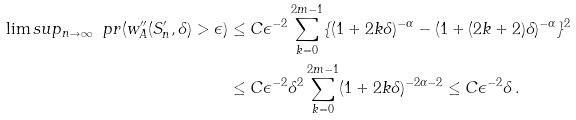Convert formula to latex. <formula><loc_0><loc_0><loc_500><loc_500>\lim s u p _ { n \to \infty } \ p r ( w _ { A } ^ { \prime \prime } ( S _ { n } ^ { \prime } , \delta ) > \epsilon ) & \leq C \epsilon ^ { - 2 } \sum _ { k = 0 } ^ { 2 m - 1 } \{ ( 1 + 2 k \delta ) ^ { - \alpha } - ( 1 + ( 2 k + 2 ) \delta ) ^ { - \alpha } \} ^ { 2 } \\ & \leq C \epsilon ^ { - 2 } \delta ^ { 2 } \sum _ { k = 0 } ^ { 2 m - 1 } ( 1 + 2 k \delta ) ^ { - 2 \alpha - 2 } \leq C \epsilon ^ { - 2 } \delta \, .</formula> 